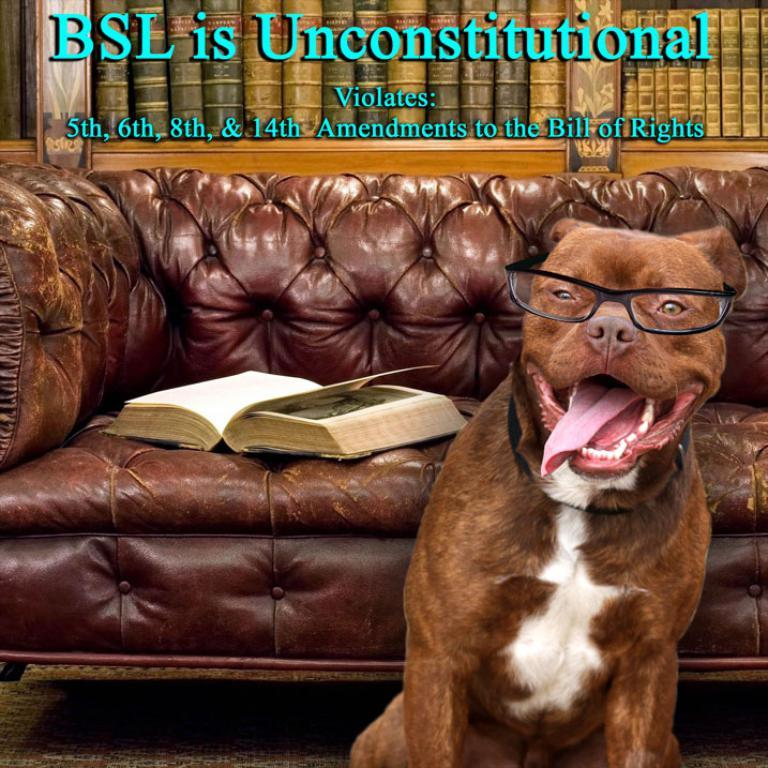What type of animal can be seen in the image? There is a dog in the image. What is located on the couch in the image? There is a book on the couch in the image. Where are more books located in the image? There are books on a bookshelf in the image. What is visible at the top of the image? There is some text visible at the top of the image. What type of wing can be seen in the image? There is no wing present in the image. How is the popcorn being used in the image? There is no popcorn present in the image. 